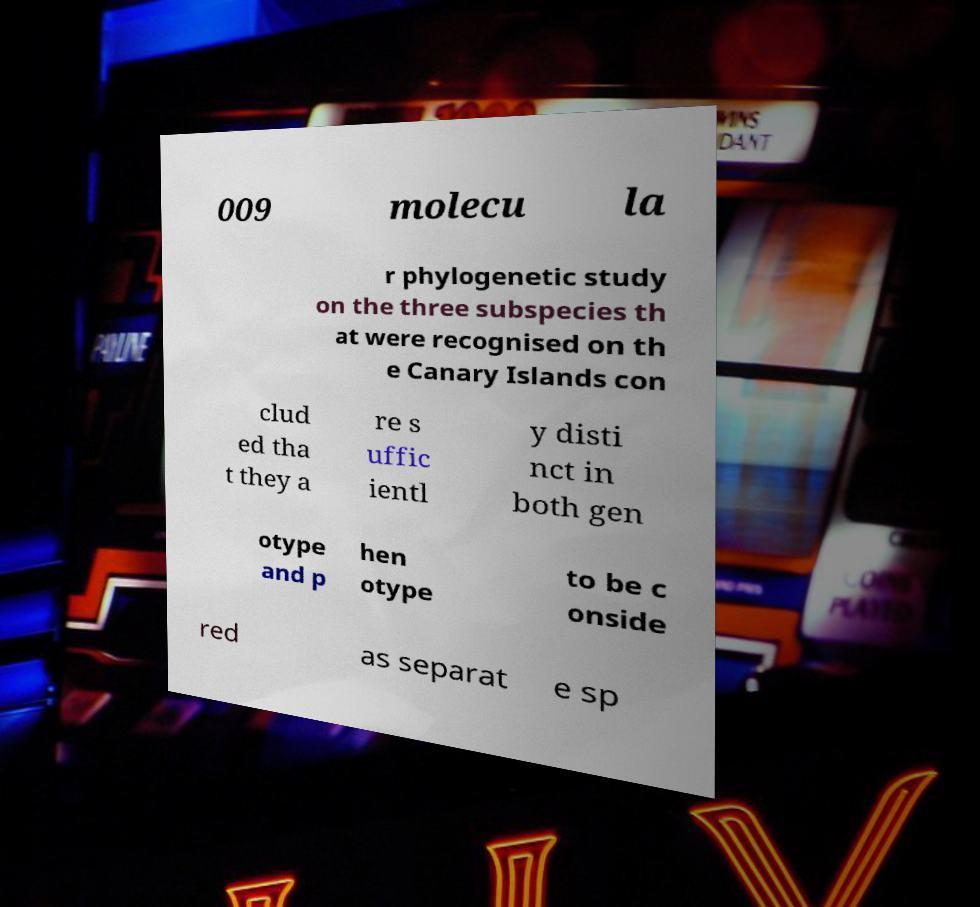Can you accurately transcribe the text from the provided image for me? 009 molecu la r phylogenetic study on the three subspecies th at were recognised on th e Canary Islands con clud ed tha t they a re s uffic ientl y disti nct in both gen otype and p hen otype to be c onside red as separat e sp 